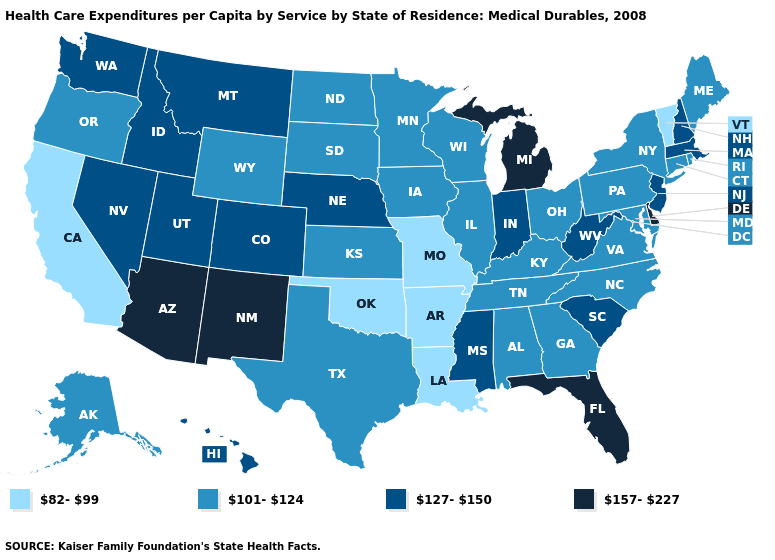Name the states that have a value in the range 101-124?
Give a very brief answer. Alabama, Alaska, Connecticut, Georgia, Illinois, Iowa, Kansas, Kentucky, Maine, Maryland, Minnesota, New York, North Carolina, North Dakota, Ohio, Oregon, Pennsylvania, Rhode Island, South Dakota, Tennessee, Texas, Virginia, Wisconsin, Wyoming. Among the states that border Tennessee , which have the lowest value?
Quick response, please. Arkansas, Missouri. Does Missouri have the lowest value in the USA?
Quick response, please. Yes. What is the lowest value in states that border Missouri?
Short answer required. 82-99. Name the states that have a value in the range 82-99?
Keep it brief. Arkansas, California, Louisiana, Missouri, Oklahoma, Vermont. Which states have the lowest value in the USA?
Answer briefly. Arkansas, California, Louisiana, Missouri, Oklahoma, Vermont. What is the value of Oklahoma?
Be succinct. 82-99. Does California have the lowest value in the West?
Be succinct. Yes. Does Vermont have the highest value in the Northeast?
Write a very short answer. No. What is the value of Arizona?
Be succinct. 157-227. Which states hav the highest value in the Northeast?
Write a very short answer. Massachusetts, New Hampshire, New Jersey. Does California have the lowest value in the West?
Concise answer only. Yes. What is the lowest value in the USA?
Quick response, please. 82-99. Does Missouri have the same value as Wyoming?
Concise answer only. No. Name the states that have a value in the range 157-227?
Concise answer only. Arizona, Delaware, Florida, Michigan, New Mexico. 